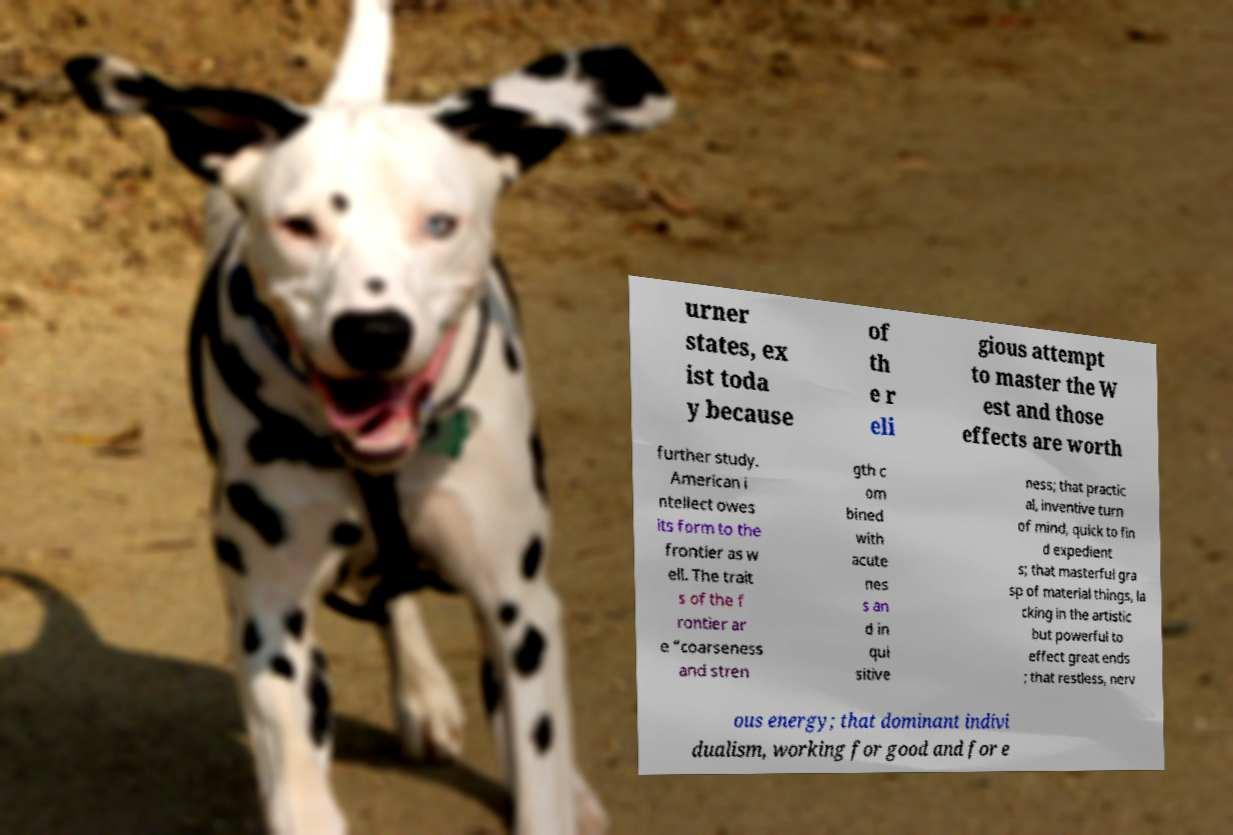Please identify and transcribe the text found in this image. urner states, ex ist toda y because of th e r eli gious attempt to master the W est and those effects are worth further study. American i ntellect owes its form to the frontier as w ell. The trait s of the f rontier ar e “coarseness and stren gth c om bined with acute nes s an d in qui sitive ness; that practic al, inventive turn of mind, quick to fin d expedient s; that masterful gra sp of material things, la cking in the artistic but powerful to effect great ends ; that restless, nerv ous energy; that dominant indivi dualism, working for good and for e 